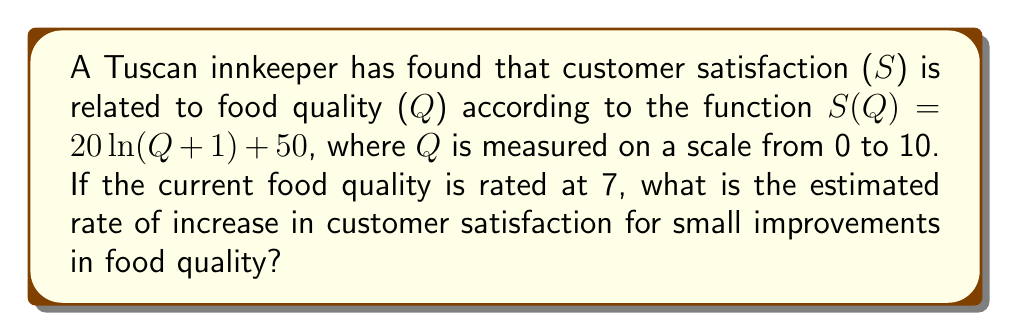Give your solution to this math problem. To find the rate of increase in customer satisfaction for small improvements in food quality, we need to calculate the derivative of the function S(Q) at Q = 7.

1. Given function: $S(Q) = 20\ln(Q+1) + 50$

2. Calculate the derivative of S(Q):
   $\frac{dS}{dQ} = \frac{d}{dQ}[20\ln(Q+1) + 50]$
   $\frac{dS}{dQ} = 20 \cdot \frac{1}{Q+1}$

3. Evaluate the derivative at Q = 7:
   $\frac{dS}{dQ}\big|_{Q=7} = 20 \cdot \frac{1}{7+1}$
   $\frac{dS}{dQ}\big|_{Q=7} = 20 \cdot \frac{1}{8}$
   $\frac{dS}{dQ}\big|_{Q=7} = \frac{20}{8} = 2.5$

This means that for small improvements in food quality near Q = 7, customer satisfaction is estimated to increase at a rate of 2.5 points per unit increase in food quality.
Answer: 2.5 points per unit increase in food quality 